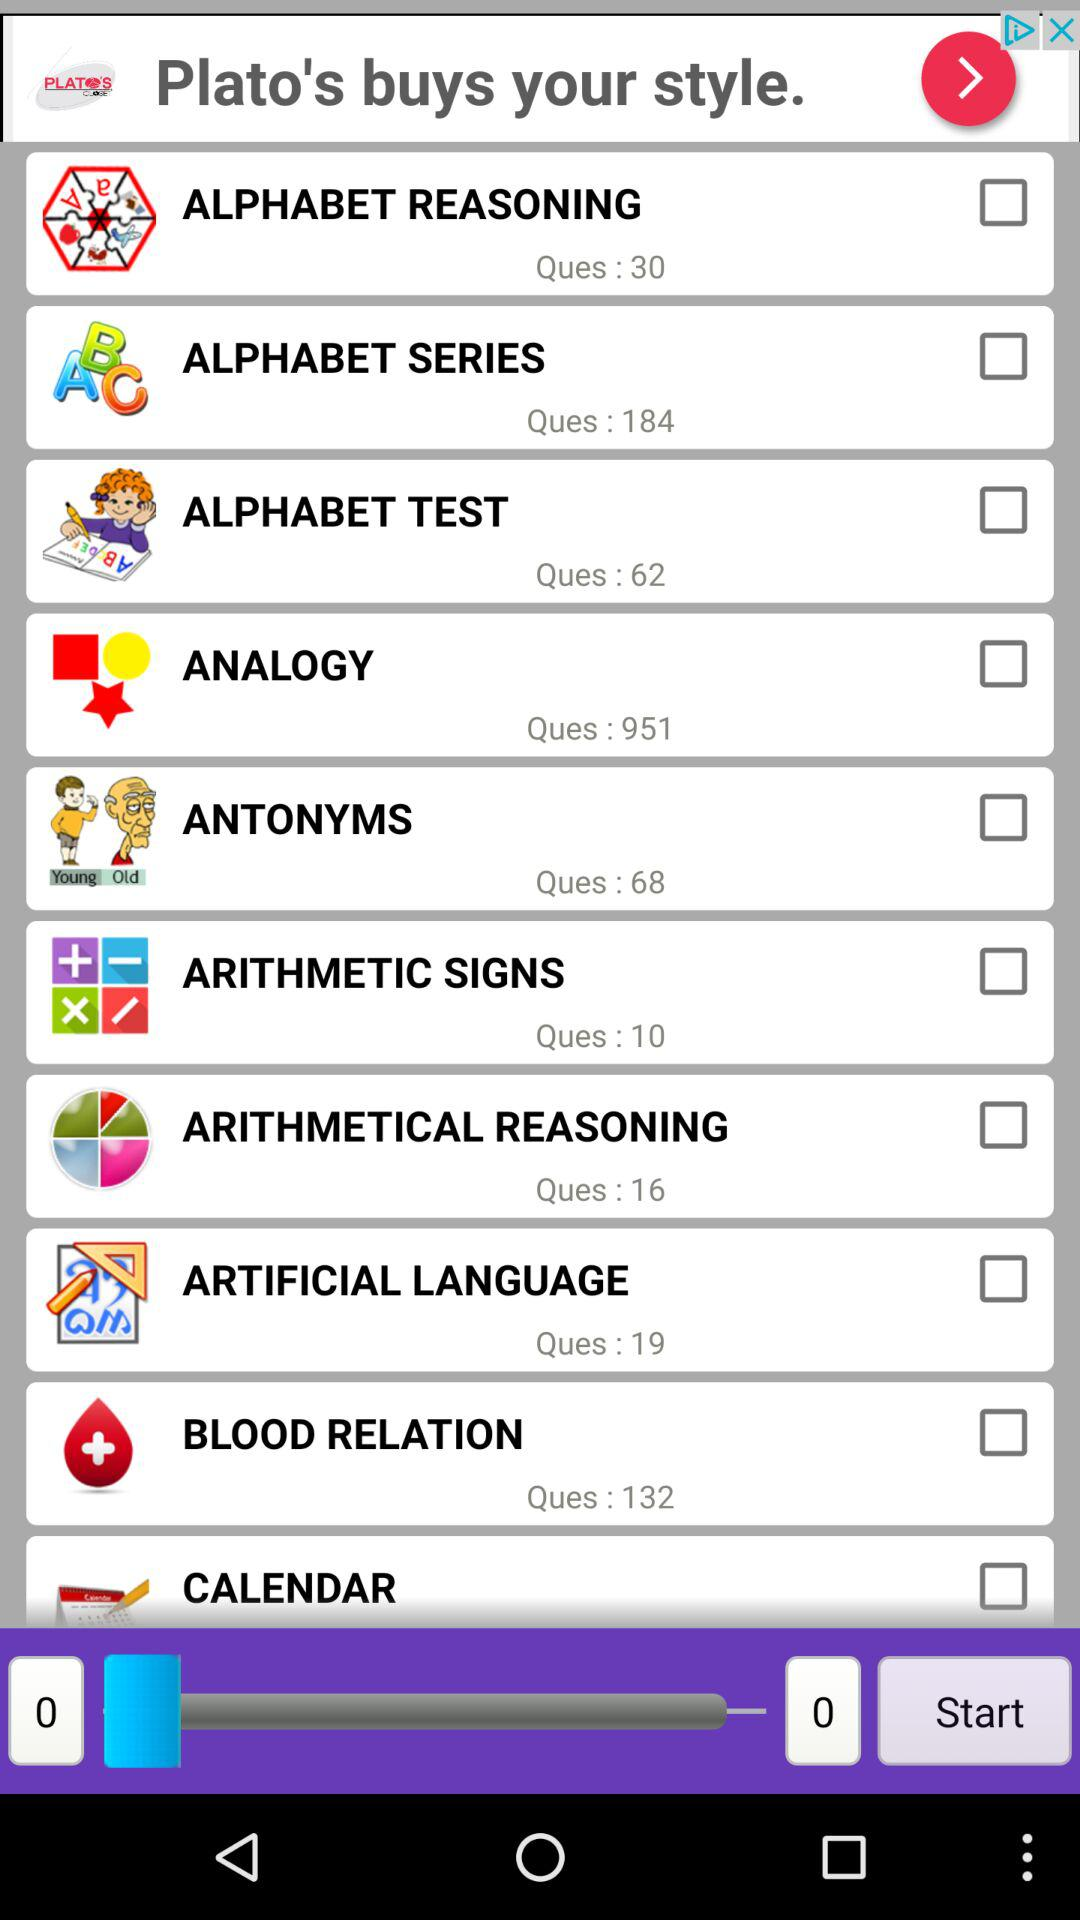How many questions are there in the "ALPHABET TEST"? There are 62 questions in the "ALPHABET TEST". 